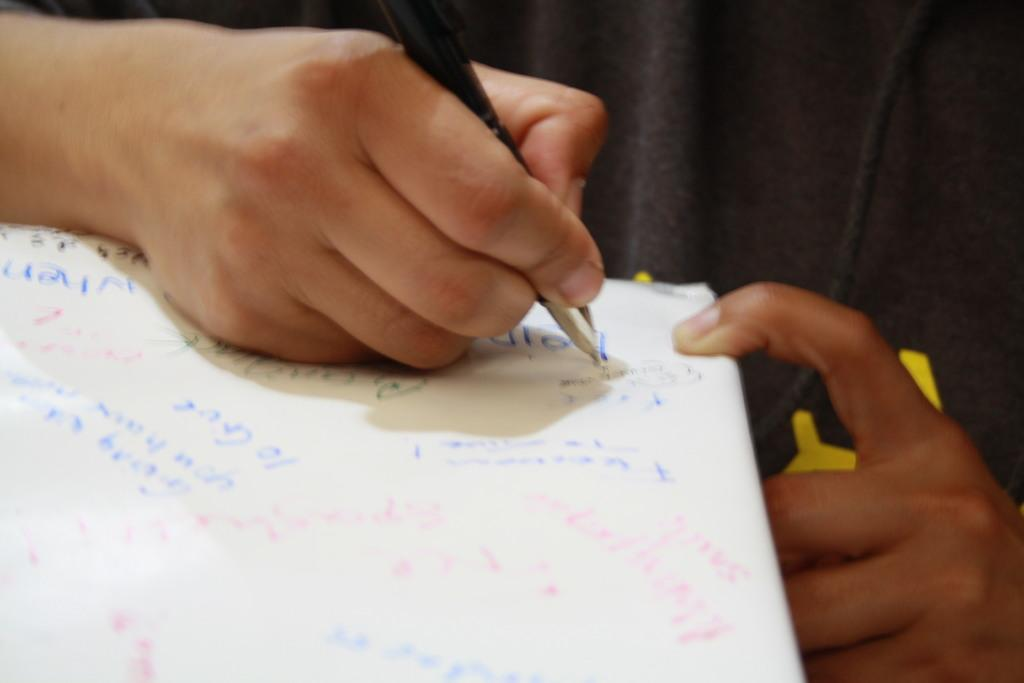What is the hand holding in the image? The hand is holding a black pen in the image. What is the hand doing with the pen? The hand is writing on a white paper. What is the color of the paper being written on? The paper being written on is white. What is the color of the background in the image? The background of the image is black. What type of plane can be seen flying in the background of the image? There is no plane visible in the image; the background is black. What sound does the pen make while writing on the paper in the image? The image does not provide any information about the sound made by the pen while writing. 